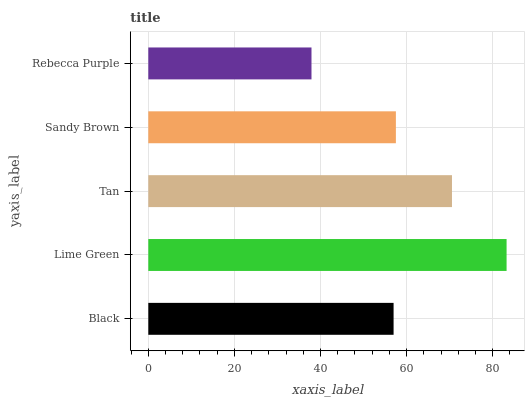Is Rebecca Purple the minimum?
Answer yes or no. Yes. Is Lime Green the maximum?
Answer yes or no. Yes. Is Tan the minimum?
Answer yes or no. No. Is Tan the maximum?
Answer yes or no. No. Is Lime Green greater than Tan?
Answer yes or no. Yes. Is Tan less than Lime Green?
Answer yes or no. Yes. Is Tan greater than Lime Green?
Answer yes or no. No. Is Lime Green less than Tan?
Answer yes or no. No. Is Sandy Brown the high median?
Answer yes or no. Yes. Is Sandy Brown the low median?
Answer yes or no. Yes. Is Tan the high median?
Answer yes or no. No. Is Tan the low median?
Answer yes or no. No. 